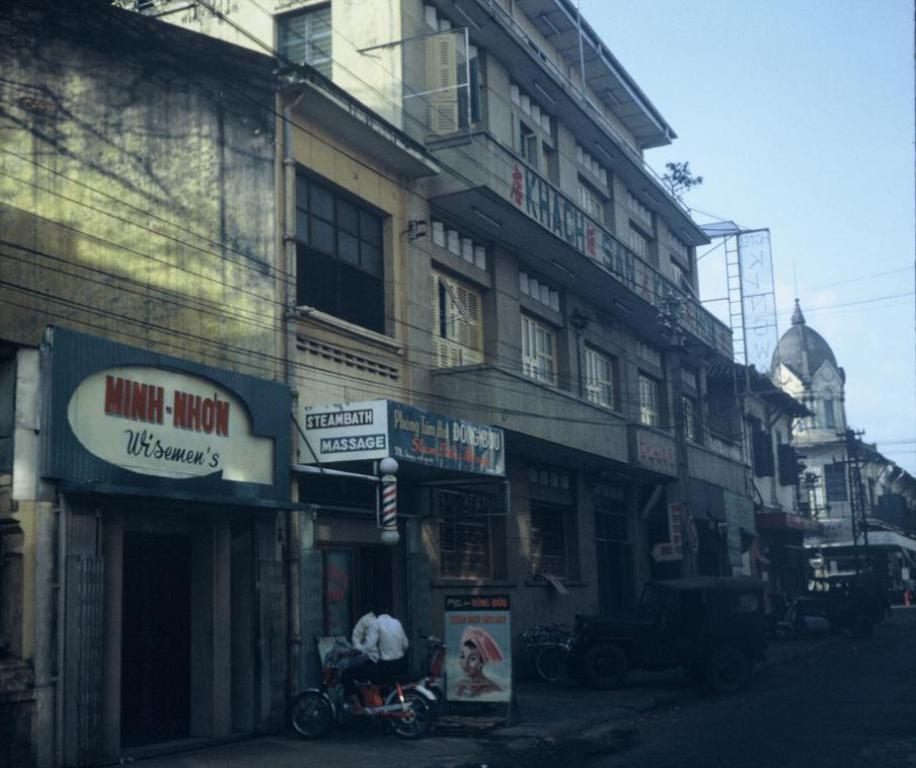Can you describe this image briefly? In this image in front there is a road. Beside the road there are vehicles. There is a tower. In the background of the image there are buildings and sky. 